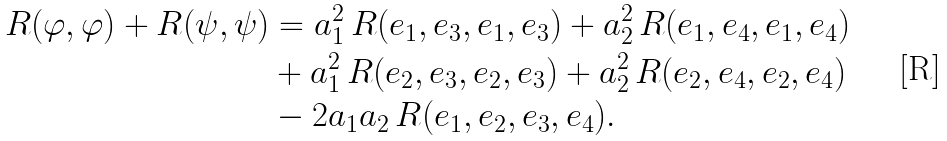Convert formula to latex. <formula><loc_0><loc_0><loc_500><loc_500>R ( \varphi , \varphi ) + R ( \psi , \psi ) & = a _ { 1 } ^ { 2 } \, R ( e _ { 1 } , e _ { 3 } , e _ { 1 } , e _ { 3 } ) + a _ { 2 } ^ { 2 } \, R ( e _ { 1 } , e _ { 4 } , e _ { 1 } , e _ { 4 } ) \\ & + a _ { 1 } ^ { 2 } \, R ( e _ { 2 } , e _ { 3 } , e _ { 2 } , e _ { 3 } ) + a _ { 2 } ^ { 2 } \, R ( e _ { 2 } , e _ { 4 } , e _ { 2 } , e _ { 4 } ) \\ & - 2 a _ { 1 } a _ { 2 } \, R ( e _ { 1 } , e _ { 2 } , e _ { 3 } , e _ { 4 } ) .</formula> 